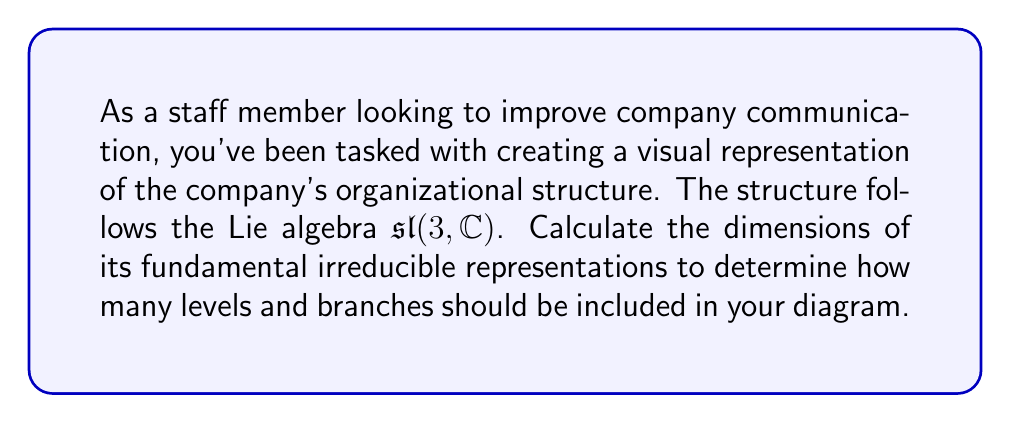Help me with this question. To calculate the dimensions of the fundamental irreducible representations of $\mathfrak{sl}(3, \mathbb{C})$, we'll follow these steps:

1) The Lie algebra $\mathfrak{sl}(3, \mathbb{C})$ has rank 2, so it has two fundamental representations.

2) For $\mathfrak{sl}(n, \mathbb{C})$, the fundamental representations correspond to the exterior powers of the standard representation.

3) The dimensions of these representations are given by the binomial coefficients:

   $$\dim V(\omega_k) = \binom{n}{k}$$

   where $\omega_k$ is the $k$-th fundamental weight.

4) For $\mathfrak{sl}(3, \mathbb{C})$, we have $n=3$ and $k=1,2$:

   For $k=1$: $\dim V(\omega_1) = \binom{3}{1} = 3$
   For $k=2$: $\dim V(\omega_2) = \binom{3}{2} = 3$

5) Therefore, both fundamental irreducible representations of $\mathfrak{sl}(3, \mathbb{C})$ have dimension 3.

This means your organizational diagram should have 3 main branches at each of the two fundamental levels.
Answer: 3, 3 